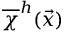<formula> <loc_0><loc_0><loc_500><loc_500>\overline { \chi } ^ { h } ( \vec { x } )</formula> 